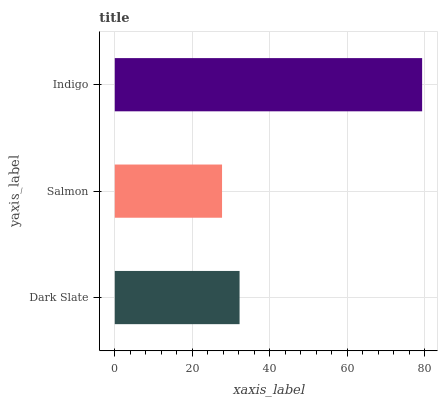Is Salmon the minimum?
Answer yes or no. Yes. Is Indigo the maximum?
Answer yes or no. Yes. Is Indigo the minimum?
Answer yes or no. No. Is Salmon the maximum?
Answer yes or no. No. Is Indigo greater than Salmon?
Answer yes or no. Yes. Is Salmon less than Indigo?
Answer yes or no. Yes. Is Salmon greater than Indigo?
Answer yes or no. No. Is Indigo less than Salmon?
Answer yes or no. No. Is Dark Slate the high median?
Answer yes or no. Yes. Is Dark Slate the low median?
Answer yes or no. Yes. Is Indigo the high median?
Answer yes or no. No. Is Salmon the low median?
Answer yes or no. No. 